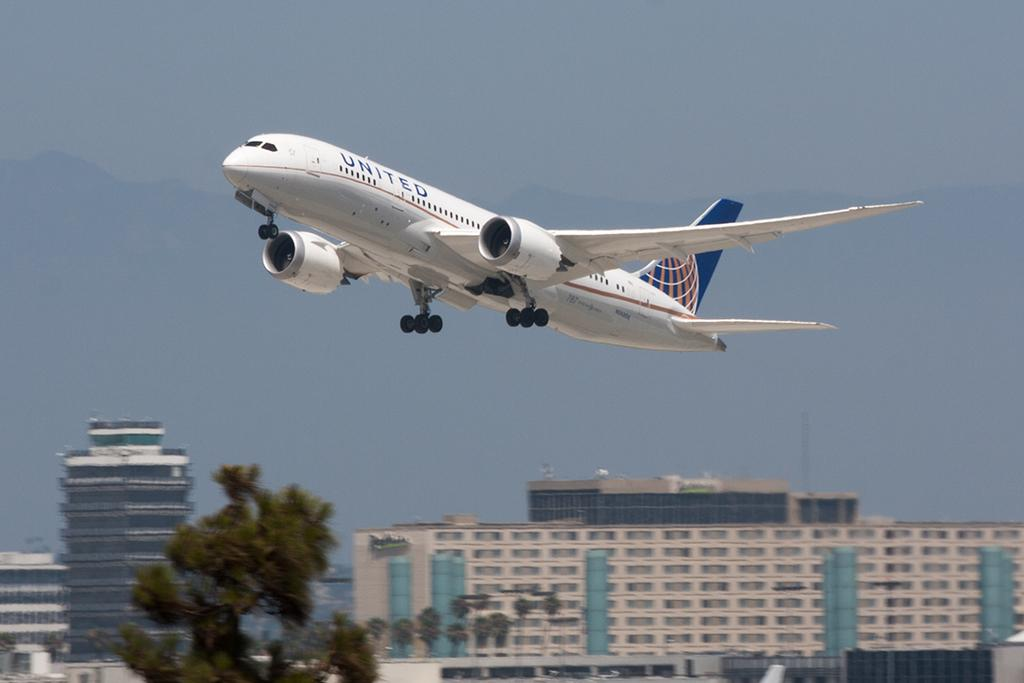<image>
Share a concise interpretation of the image provided. A United plane is taking off with a building in the background. 